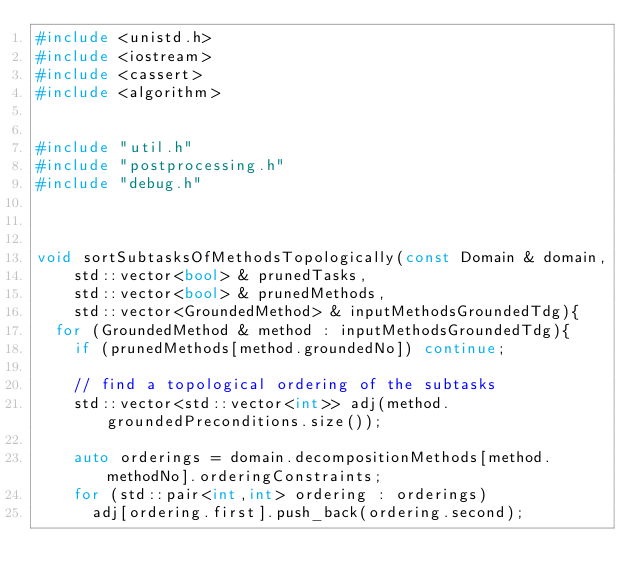Convert code to text. <code><loc_0><loc_0><loc_500><loc_500><_C++_>#include <unistd.h>
#include <iostream>
#include <cassert>
#include <algorithm>


#include "util.h"
#include "postprocessing.h"
#include "debug.h"



void sortSubtasksOfMethodsTopologically(const Domain & domain,
		std::vector<bool> & prunedTasks,
		std::vector<bool> & prunedMethods,
		std::vector<GroundedMethod> & inputMethodsGroundedTdg){
	for (GroundedMethod & method : inputMethodsGroundedTdg){
		if (prunedMethods[method.groundedNo]) continue;
		
		// find a topological ordering of the subtasks
		std::vector<std::vector<int>> adj(method.groundedPreconditions.size());
		
		auto orderings = domain.decompositionMethods[method.methodNo].orderingConstraints;
		for (std::pair<int,int> ordering : orderings)
			adj[ordering.first].push_back(ordering.second);
</code> 